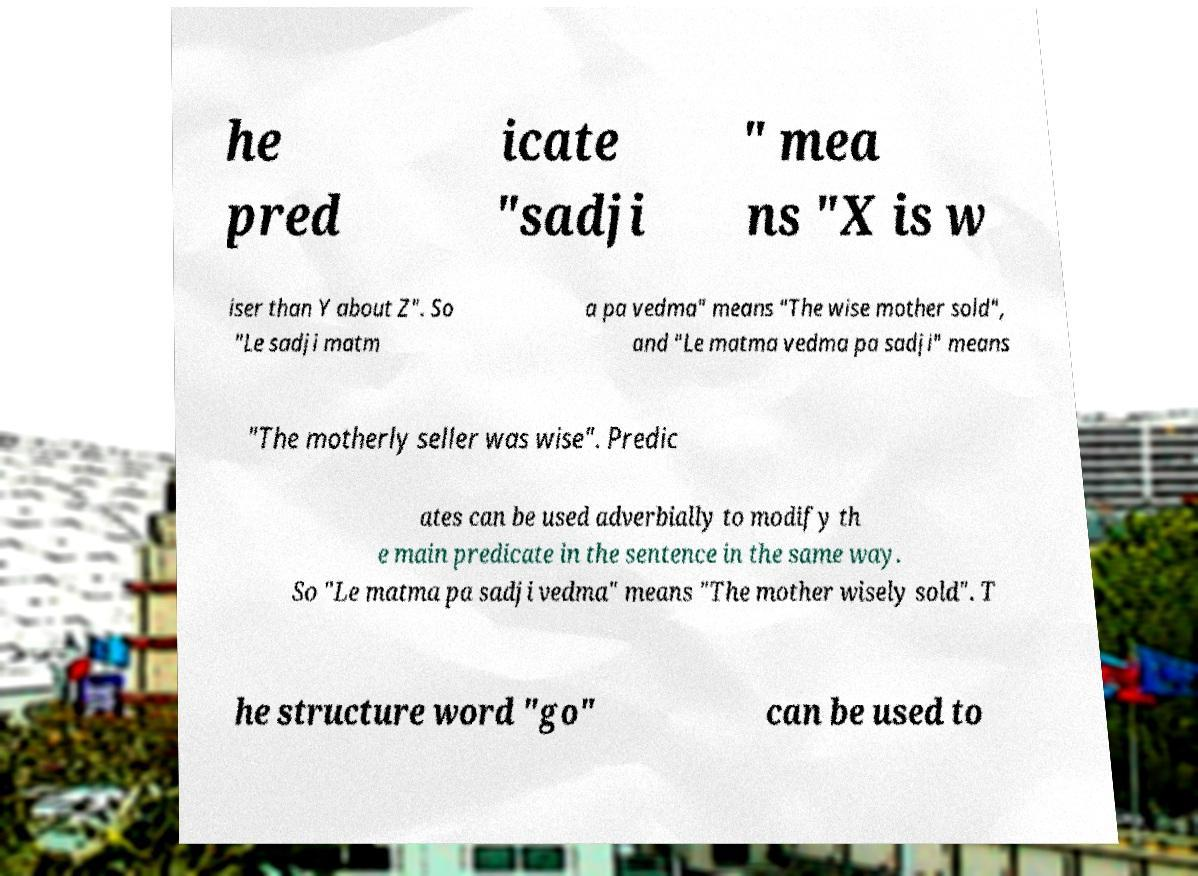Please identify and transcribe the text found in this image. he pred icate "sadji " mea ns "X is w iser than Y about Z". So "Le sadji matm a pa vedma" means "The wise mother sold", and "Le matma vedma pa sadji" means "The motherly seller was wise". Predic ates can be used adverbially to modify th e main predicate in the sentence in the same way. So "Le matma pa sadji vedma" means "The mother wisely sold". T he structure word "go" can be used to 